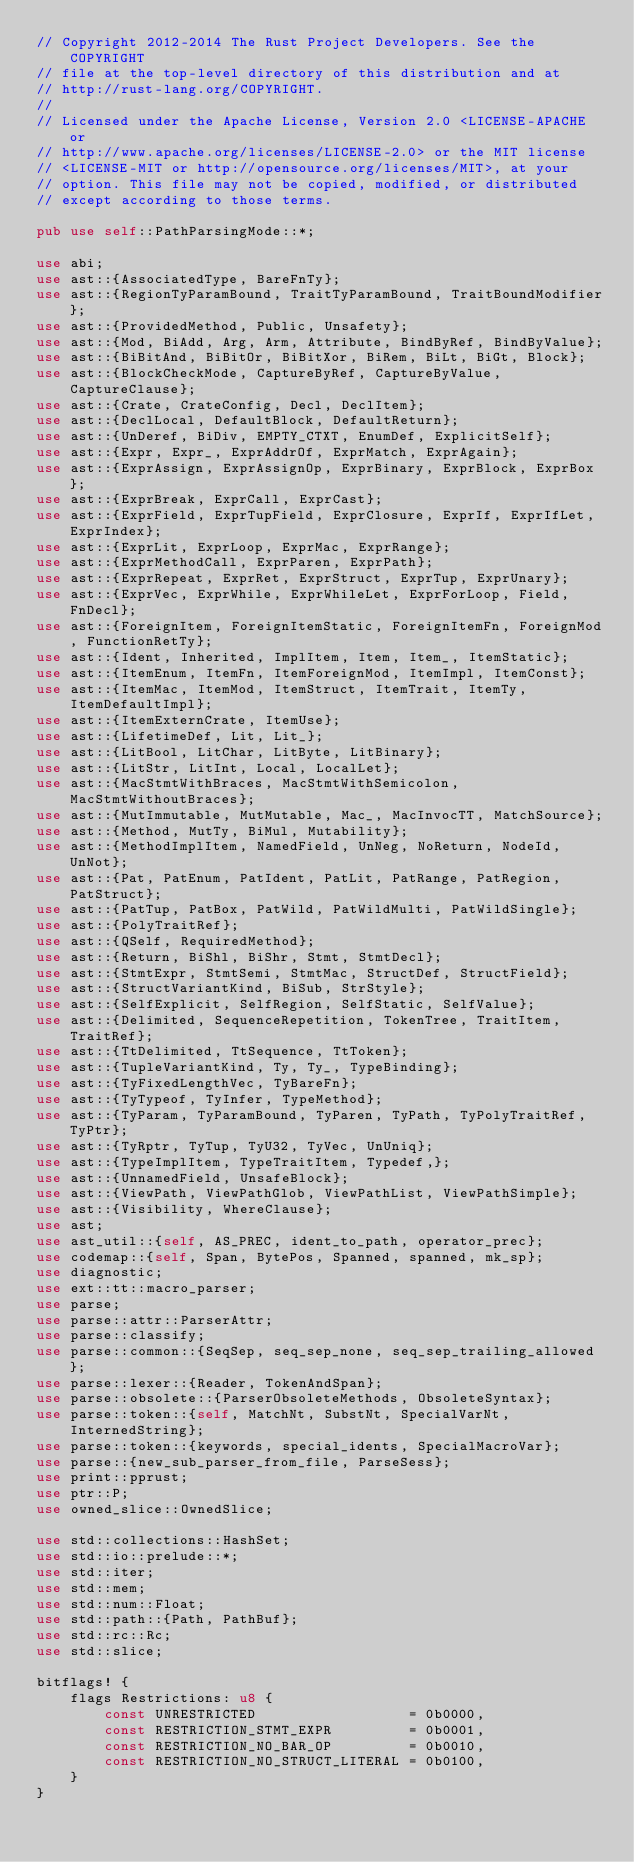Convert code to text. <code><loc_0><loc_0><loc_500><loc_500><_Rust_>// Copyright 2012-2014 The Rust Project Developers. See the COPYRIGHT
// file at the top-level directory of this distribution and at
// http://rust-lang.org/COPYRIGHT.
//
// Licensed under the Apache License, Version 2.0 <LICENSE-APACHE or
// http://www.apache.org/licenses/LICENSE-2.0> or the MIT license
// <LICENSE-MIT or http://opensource.org/licenses/MIT>, at your
// option. This file may not be copied, modified, or distributed
// except according to those terms.

pub use self::PathParsingMode::*;

use abi;
use ast::{AssociatedType, BareFnTy};
use ast::{RegionTyParamBound, TraitTyParamBound, TraitBoundModifier};
use ast::{ProvidedMethod, Public, Unsafety};
use ast::{Mod, BiAdd, Arg, Arm, Attribute, BindByRef, BindByValue};
use ast::{BiBitAnd, BiBitOr, BiBitXor, BiRem, BiLt, BiGt, Block};
use ast::{BlockCheckMode, CaptureByRef, CaptureByValue, CaptureClause};
use ast::{Crate, CrateConfig, Decl, DeclItem};
use ast::{DeclLocal, DefaultBlock, DefaultReturn};
use ast::{UnDeref, BiDiv, EMPTY_CTXT, EnumDef, ExplicitSelf};
use ast::{Expr, Expr_, ExprAddrOf, ExprMatch, ExprAgain};
use ast::{ExprAssign, ExprAssignOp, ExprBinary, ExprBlock, ExprBox};
use ast::{ExprBreak, ExprCall, ExprCast};
use ast::{ExprField, ExprTupField, ExprClosure, ExprIf, ExprIfLet, ExprIndex};
use ast::{ExprLit, ExprLoop, ExprMac, ExprRange};
use ast::{ExprMethodCall, ExprParen, ExprPath};
use ast::{ExprRepeat, ExprRet, ExprStruct, ExprTup, ExprUnary};
use ast::{ExprVec, ExprWhile, ExprWhileLet, ExprForLoop, Field, FnDecl};
use ast::{ForeignItem, ForeignItemStatic, ForeignItemFn, ForeignMod, FunctionRetTy};
use ast::{Ident, Inherited, ImplItem, Item, Item_, ItemStatic};
use ast::{ItemEnum, ItemFn, ItemForeignMod, ItemImpl, ItemConst};
use ast::{ItemMac, ItemMod, ItemStruct, ItemTrait, ItemTy, ItemDefaultImpl};
use ast::{ItemExternCrate, ItemUse};
use ast::{LifetimeDef, Lit, Lit_};
use ast::{LitBool, LitChar, LitByte, LitBinary};
use ast::{LitStr, LitInt, Local, LocalLet};
use ast::{MacStmtWithBraces, MacStmtWithSemicolon, MacStmtWithoutBraces};
use ast::{MutImmutable, MutMutable, Mac_, MacInvocTT, MatchSource};
use ast::{Method, MutTy, BiMul, Mutability};
use ast::{MethodImplItem, NamedField, UnNeg, NoReturn, NodeId, UnNot};
use ast::{Pat, PatEnum, PatIdent, PatLit, PatRange, PatRegion, PatStruct};
use ast::{PatTup, PatBox, PatWild, PatWildMulti, PatWildSingle};
use ast::{PolyTraitRef};
use ast::{QSelf, RequiredMethod};
use ast::{Return, BiShl, BiShr, Stmt, StmtDecl};
use ast::{StmtExpr, StmtSemi, StmtMac, StructDef, StructField};
use ast::{StructVariantKind, BiSub, StrStyle};
use ast::{SelfExplicit, SelfRegion, SelfStatic, SelfValue};
use ast::{Delimited, SequenceRepetition, TokenTree, TraitItem, TraitRef};
use ast::{TtDelimited, TtSequence, TtToken};
use ast::{TupleVariantKind, Ty, Ty_, TypeBinding};
use ast::{TyFixedLengthVec, TyBareFn};
use ast::{TyTypeof, TyInfer, TypeMethod};
use ast::{TyParam, TyParamBound, TyParen, TyPath, TyPolyTraitRef, TyPtr};
use ast::{TyRptr, TyTup, TyU32, TyVec, UnUniq};
use ast::{TypeImplItem, TypeTraitItem, Typedef,};
use ast::{UnnamedField, UnsafeBlock};
use ast::{ViewPath, ViewPathGlob, ViewPathList, ViewPathSimple};
use ast::{Visibility, WhereClause};
use ast;
use ast_util::{self, AS_PREC, ident_to_path, operator_prec};
use codemap::{self, Span, BytePos, Spanned, spanned, mk_sp};
use diagnostic;
use ext::tt::macro_parser;
use parse;
use parse::attr::ParserAttr;
use parse::classify;
use parse::common::{SeqSep, seq_sep_none, seq_sep_trailing_allowed};
use parse::lexer::{Reader, TokenAndSpan};
use parse::obsolete::{ParserObsoleteMethods, ObsoleteSyntax};
use parse::token::{self, MatchNt, SubstNt, SpecialVarNt, InternedString};
use parse::token::{keywords, special_idents, SpecialMacroVar};
use parse::{new_sub_parser_from_file, ParseSess};
use print::pprust;
use ptr::P;
use owned_slice::OwnedSlice;

use std::collections::HashSet;
use std::io::prelude::*;
use std::iter;
use std::mem;
use std::num::Float;
use std::path::{Path, PathBuf};
use std::rc::Rc;
use std::slice;

bitflags! {
    flags Restrictions: u8 {
        const UNRESTRICTED                  = 0b0000,
        const RESTRICTION_STMT_EXPR         = 0b0001,
        const RESTRICTION_NO_BAR_OP         = 0b0010,
        const RESTRICTION_NO_STRUCT_LITERAL = 0b0100,
    }
}

</code> 